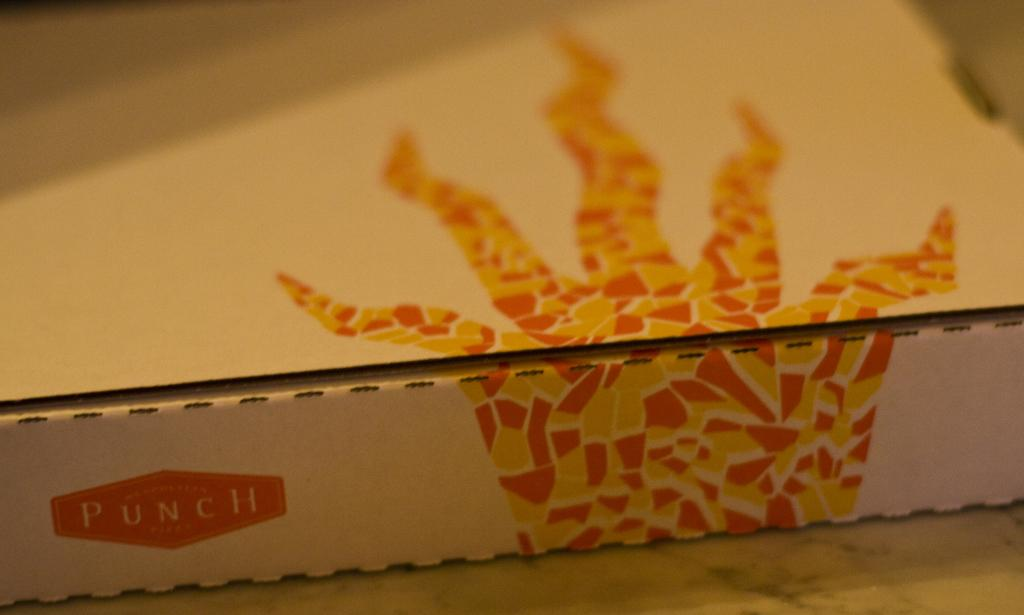Provide a one-sentence caption for the provided image. Punch is the name on the pizza box. 